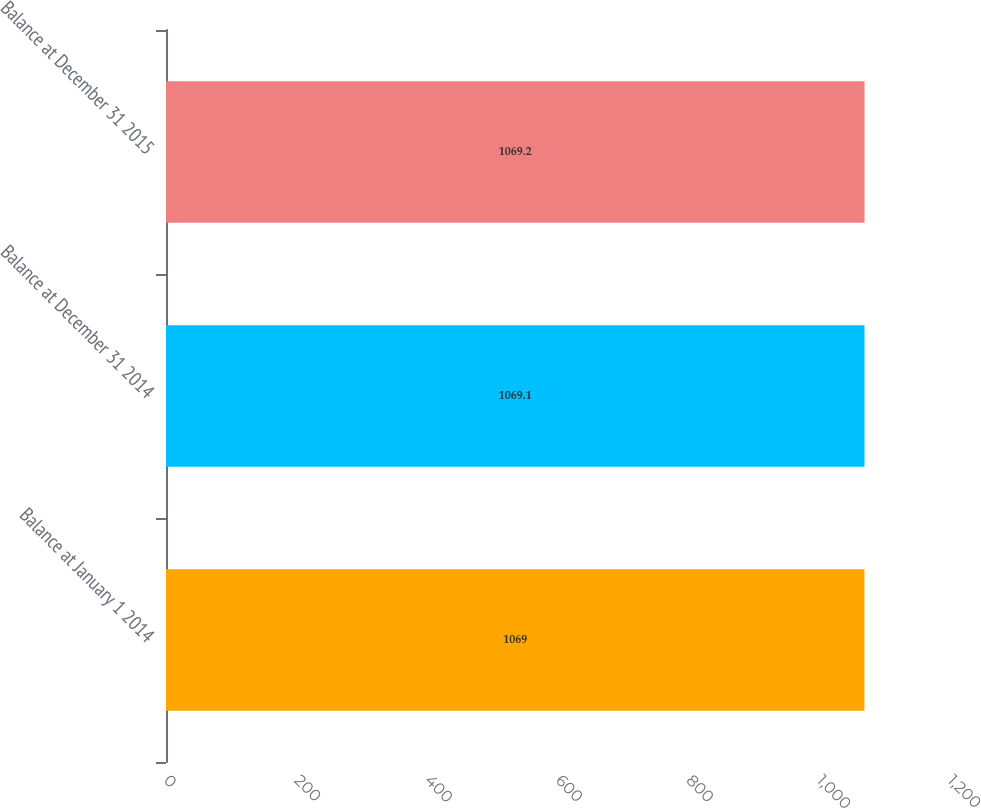<chart> <loc_0><loc_0><loc_500><loc_500><bar_chart><fcel>Balance at January 1 2014<fcel>Balance at December 31 2014<fcel>Balance at December 31 2015<nl><fcel>1069<fcel>1069.1<fcel>1069.2<nl></chart> 